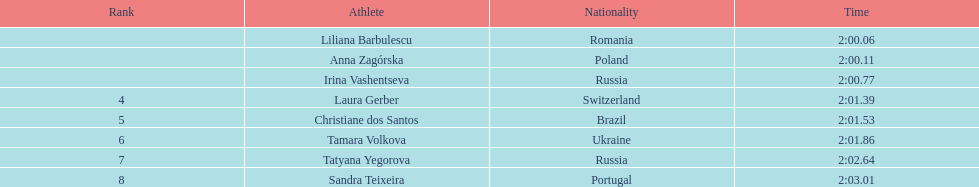In regards to anna zagorska, what was her finishing time? 2:00.11. 